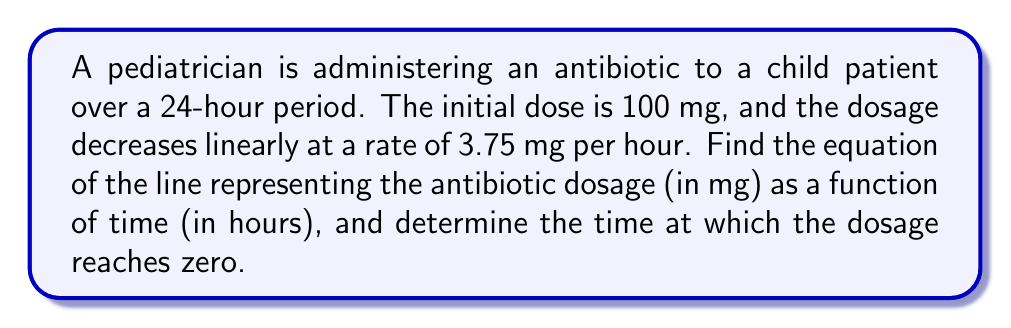Can you solve this math problem? To solve this problem, we'll use the point-slope form of a line equation and then convert it to slope-intercept form.

1. Identify the given information:
   - Initial dose (y-intercept): 100 mg
   - Rate of decrease (slope): -3.75 mg/hour

2. Use the point-slope form of a line equation:
   $$(y - y_1) = m(x - x_1)$$
   where $(x_1, y_1)$ is a point on the line, and $m$ is the slope.

3. We can use the initial point (0, 100) and the given slope:
   $$(y - 100) = -3.75(x - 0)$$

4. Simplify the equation:
   $$y - 100 = -3.75x$$

5. Rearrange to slope-intercept form $(y = mx + b)$:
   $$y = -3.75x + 100$$

This is the equation of the line representing the antibiotic dosage over time.

6. To find when the dosage reaches zero, set $y = 0$ and solve for $x$:
   $$0 = -3.75x + 100$$
   $$3.75x = 100$$
   $$x = \frac{100}{3.75} = 26.67$$

Therefore, the dosage reaches zero after approximately 26.67 hours.
Answer: Equation of the line: $y = -3.75x + 100$, where $y$ is the dosage in mg and $x$ is the time in hours.
Time when dosage reaches zero: 26.67 hours 